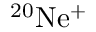Convert formula to latex. <formula><loc_0><loc_0><loc_500><loc_500>^ { 2 0 } N e ^ { + }</formula> 